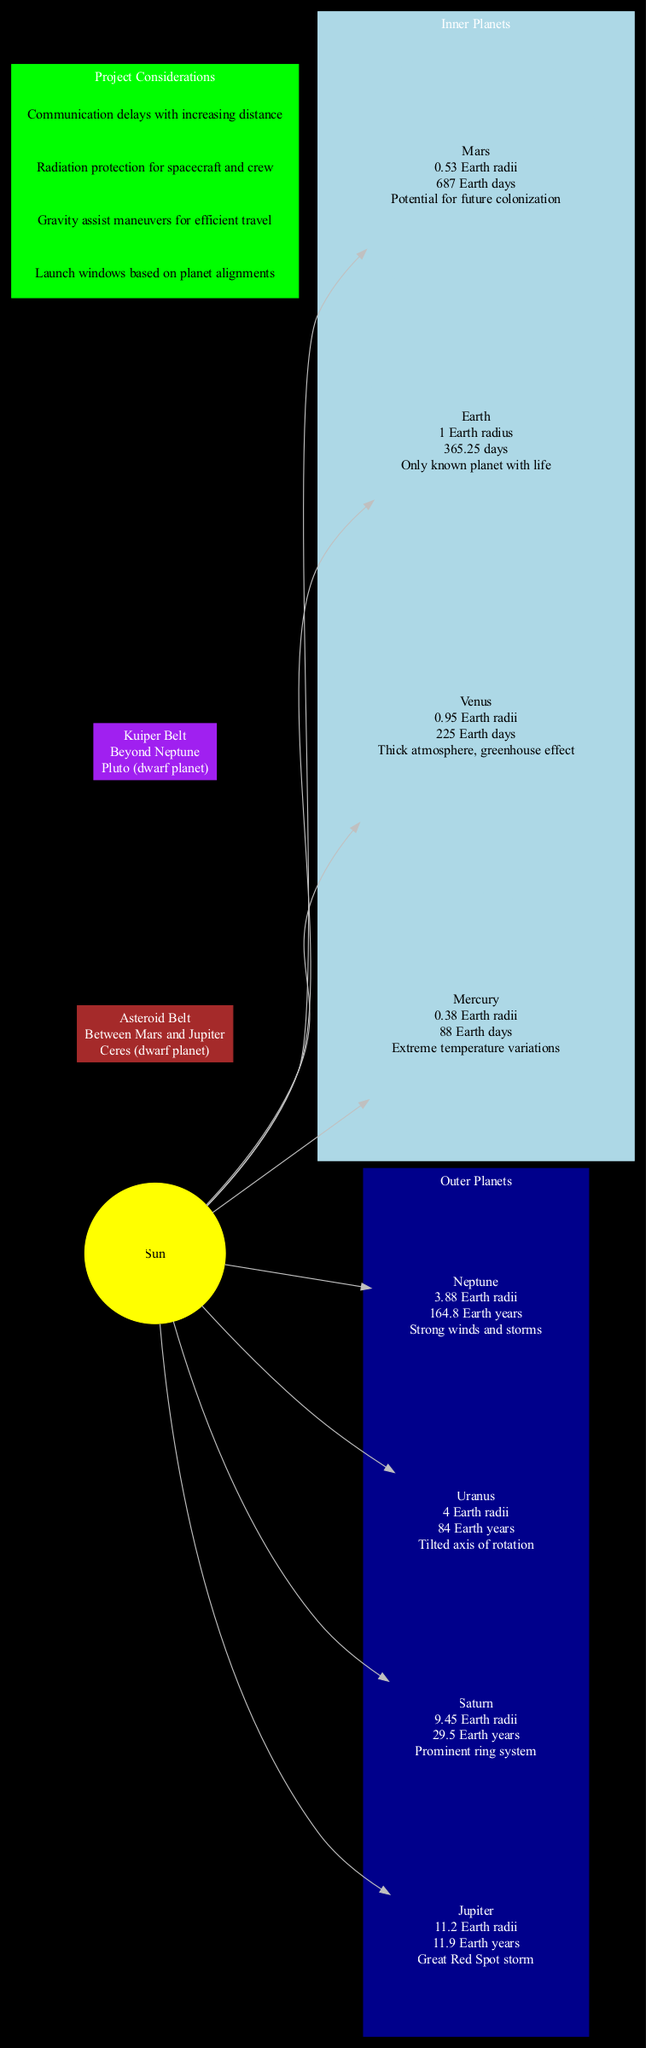What is the size of Mars? Mars is indicated as having a size of 0.53 Earth radii in the diagram.
Answer: 0.53 Earth radii How long does it take Jupiter to orbit the Sun? According to the diagram, Jupiter's orbital period is noted as 11.9 Earth years.
Answer: 11.9 Earth years Name a notable object found in the asteroid belt. The diagram specifies that Ceres, a dwarf planet, is located in the asteroid belt.
Answer: Ceres (dwarf planet) Which planet has a thick atmosphere and greenhouse effect? The diagram identifies Venus as having a thick atmosphere and the greenhouse effect as its key feature.
Answer: Venus What are two project considerations listed in the diagram? The diagram lists project considerations including "Launch windows based on planet alignments" and "Gravity assist maneuvers for efficient travel."
Answer: Launch windows based on planet alignments, Gravity assist maneuvers for efficient travel Which planet features the Great Red Spot storm? The Great Red Spot storm is associated with Jupiter, as noted in the diagram.
Answer: Jupiter In what location is the Kuiper Belt found? The diagram shows that the Kuiper Belt is located beyond Neptune.
Answer: Beyond Neptune How many inner planets are included in the diagram? The diagram displays four inner planets: Mercury, Venus, Earth, and Mars, leading to a total count of four.
Answer: 4 What is the prominent feature of Saturn? The diagram indicates that Saturn has a prominent ring system as its key feature.
Answer: Prominent ring system 